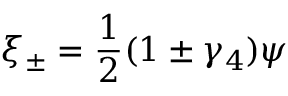Convert formula to latex. <formula><loc_0><loc_0><loc_500><loc_500>\xi _ { \pm } = \frac { 1 } { 2 } ( 1 \pm \gamma _ { 4 } ) \psi</formula> 